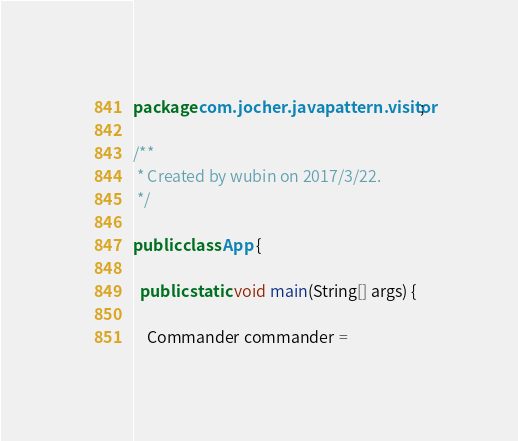<code> <loc_0><loc_0><loc_500><loc_500><_Java_>package com.jocher.javapattern.visitor;

/**
 * Created by wubin on 2017/3/22.
 */

public class App {

  public static void main(String[] args) {

    Commander commander =</code> 